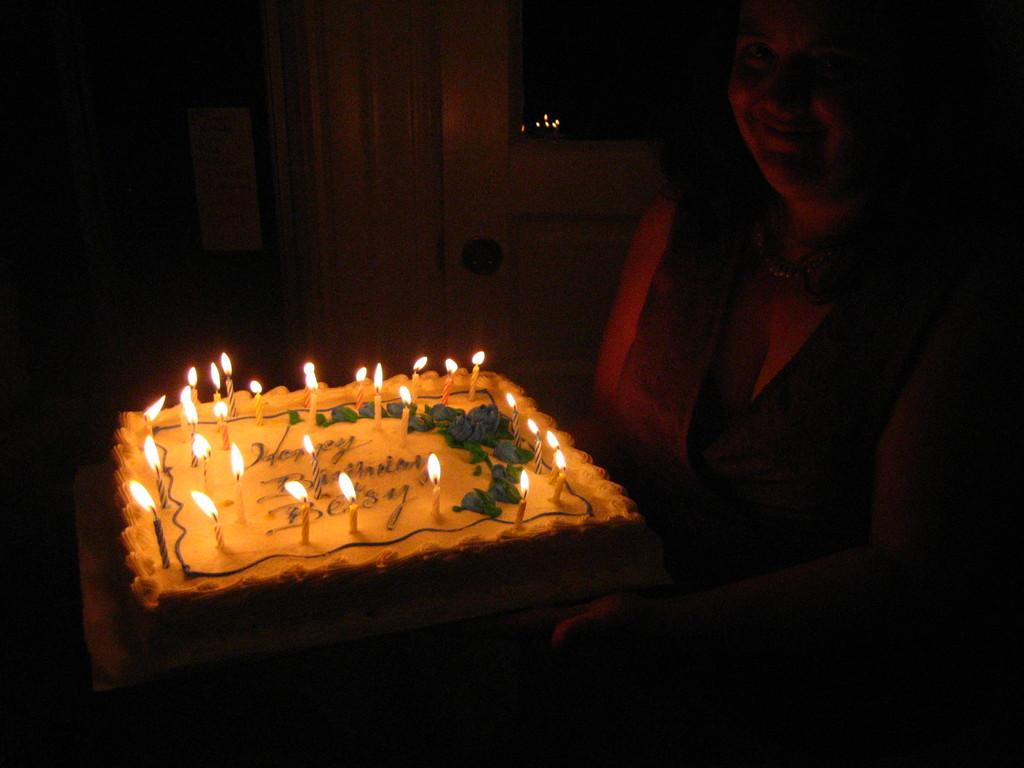What is the woman doing in the image? The woman is standing in the image and holding a cake. Where is the cake located in relation to the woman? The cake is in the middle of the image. What can be seen in the background of the image? There is a wall in the background of the image. How many shelves can be seen holding the rolls in the image? There are no shelves or rolls present in the image. What type of ray is visible in the image? There is no ray visible in the image. 